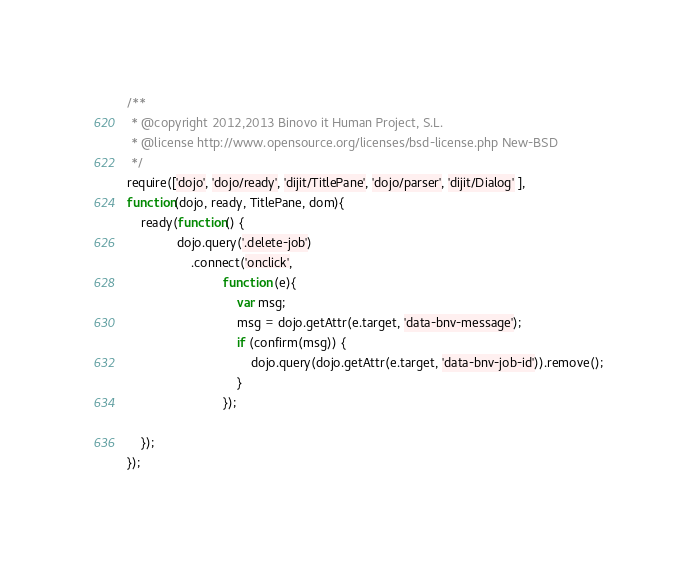<code> <loc_0><loc_0><loc_500><loc_500><_JavaScript_>/**
 * @copyright 2012,2013 Binovo it Human Project, S.L.
 * @license http://www.opensource.org/licenses/bsd-license.php New-BSD
 */
require(['dojo', 'dojo/ready', 'dijit/TitlePane', 'dojo/parser', 'dijit/Dialog' ],
function(dojo, ready, TitlePane, dom){
    ready(function() {
              dojo.query('.delete-job')
                  .connect('onclick',
                           function (e){
                               var msg;
                               msg = dojo.getAttr(e.target, 'data-bnv-message');
                               if (confirm(msg)) {
                                   dojo.query(dojo.getAttr(e.target, 'data-bnv-job-id')).remove();
                               }
                           });

    });
});
</code> 